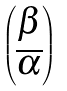<formula> <loc_0><loc_0><loc_500><loc_500>\begin{pmatrix} \beta \\ \overline { \alpha } \end{pmatrix}</formula> 